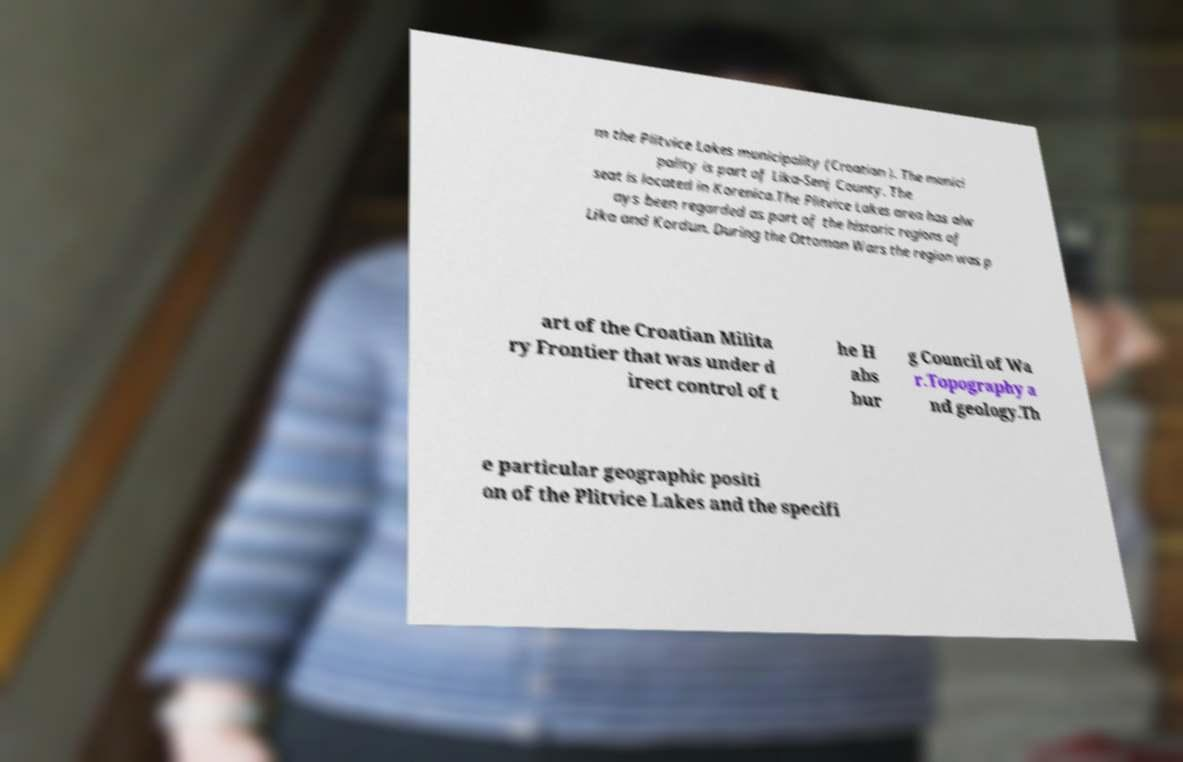There's text embedded in this image that I need extracted. Can you transcribe it verbatim? m the Plitvice Lakes municipality (Croatian ). The munici pality is part of Lika-Senj County. The seat is located in Korenica.The Plitvice Lakes area has alw ays been regarded as part of the historic regions of Lika and Kordun. During the Ottoman Wars the region was p art of the Croatian Milita ry Frontier that was under d irect control of t he H abs bur g Council of Wa r.Topography a nd geology.Th e particular geographic positi on of the Plitvice Lakes and the specifi 